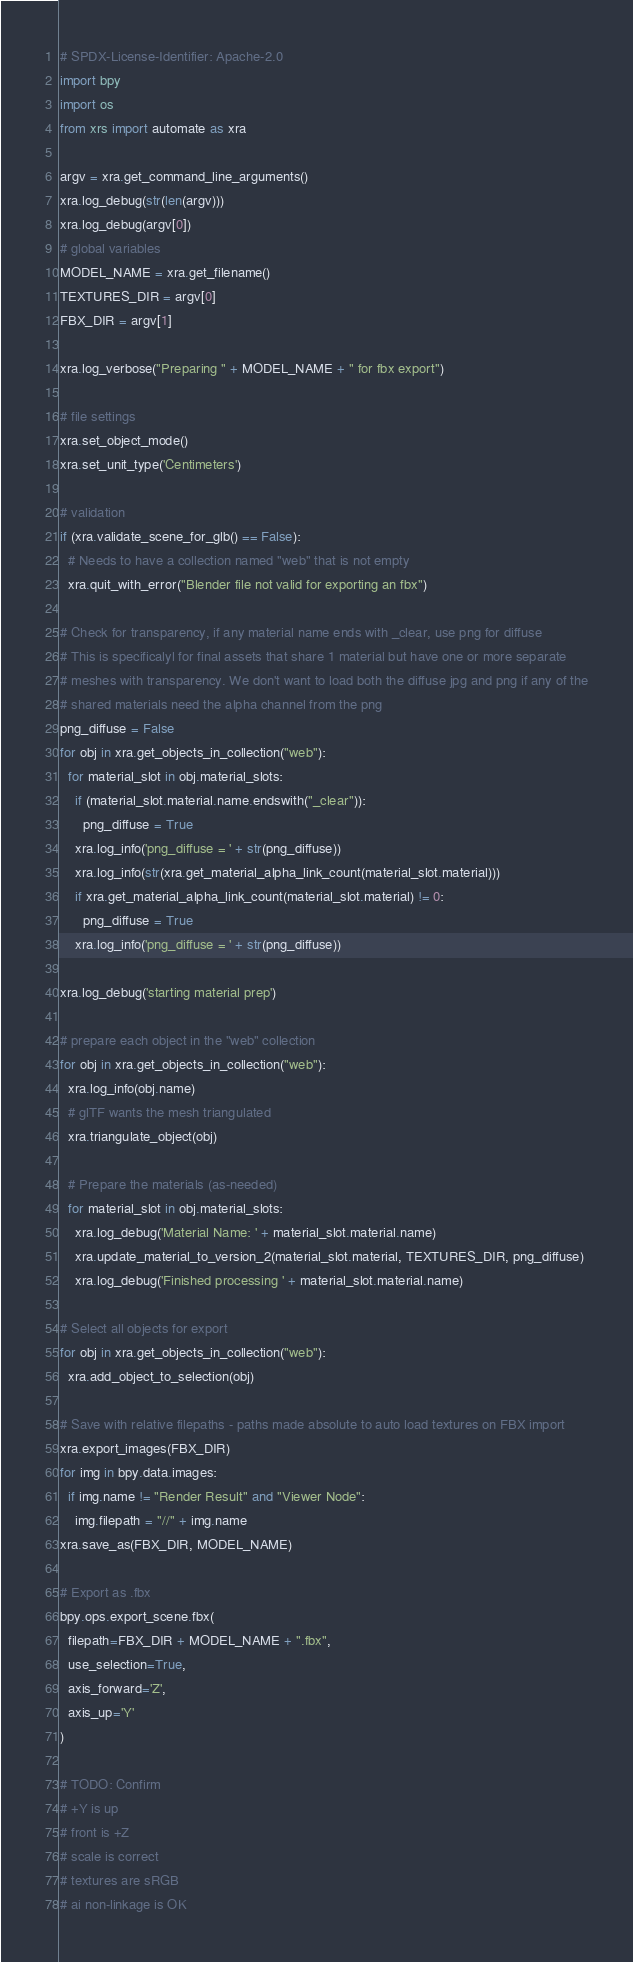Convert code to text. <code><loc_0><loc_0><loc_500><loc_500><_Python_># SPDX-License-Identifier: Apache-2.0
import bpy
import os
from xrs import automate as xra

argv = xra.get_command_line_arguments()
xra.log_debug(str(len(argv)))
xra.log_debug(argv[0])
# global variables
MODEL_NAME = xra.get_filename()
TEXTURES_DIR = argv[0]
FBX_DIR = argv[1]

xra.log_verbose("Preparing " + MODEL_NAME + " for fbx export")

# file settings
xra.set_object_mode()
xra.set_unit_type('Centimeters')

# validation
if (xra.validate_scene_for_glb() == False):
  # Needs to have a collection named "web" that is not empty
  xra.quit_with_error("Blender file not valid for exporting an fbx")

# Check for transparency, if any material name ends with _clear, use png for diffuse
# This is specificalyl for final assets that share 1 material but have one or more separate
# meshes with transparency. We don't want to load both the diffuse jpg and png if any of the
# shared materials need the alpha channel from the png
png_diffuse = False
for obj in xra.get_objects_in_collection("web"):
  for material_slot in obj.material_slots:
    if (material_slot.material.name.endswith("_clear")):
      png_diffuse = True
    xra.log_info('png_diffuse = ' + str(png_diffuse))
    xra.log_info(str(xra.get_material_alpha_link_count(material_slot.material)))
    if xra.get_material_alpha_link_count(material_slot.material) != 0:
      png_diffuse = True
    xra.log_info('png_diffuse = ' + str(png_diffuse))

xra.log_debug('starting material prep')

# prepare each object in the "web" collection
for obj in xra.get_objects_in_collection("web"):
  xra.log_info(obj.name)
  # glTF wants the mesh triangulated
  xra.triangulate_object(obj)

  # Prepare the materials (as-needed)
  for material_slot in obj.material_slots:
    xra.log_debug('Material Name: ' + material_slot.material.name)
    xra.update_material_to_version_2(material_slot.material, TEXTURES_DIR, png_diffuse)
    xra.log_debug('Finished processing ' + material_slot.material.name)

# Select all objects for export
for obj in xra.get_objects_in_collection("web"):
  xra.add_object_to_selection(obj)

# Save with relative filepaths - paths made absolute to auto load textures on FBX import
xra.export_images(FBX_DIR)
for img in bpy.data.images:
  if img.name != "Render Result" and "Viewer Node":
    img.filepath = "//" + img.name
xra.save_as(FBX_DIR, MODEL_NAME)

# Export as .fbx
bpy.ops.export_scene.fbx(
  filepath=FBX_DIR + MODEL_NAME + ".fbx",
  use_selection=True,
  axis_forward='Z',
  axis_up='Y'
)

# TODO: Confirm
# +Y is up
# front is +Z
# scale is correct
# textures are sRGB
# ai non-linkage is OK
</code> 